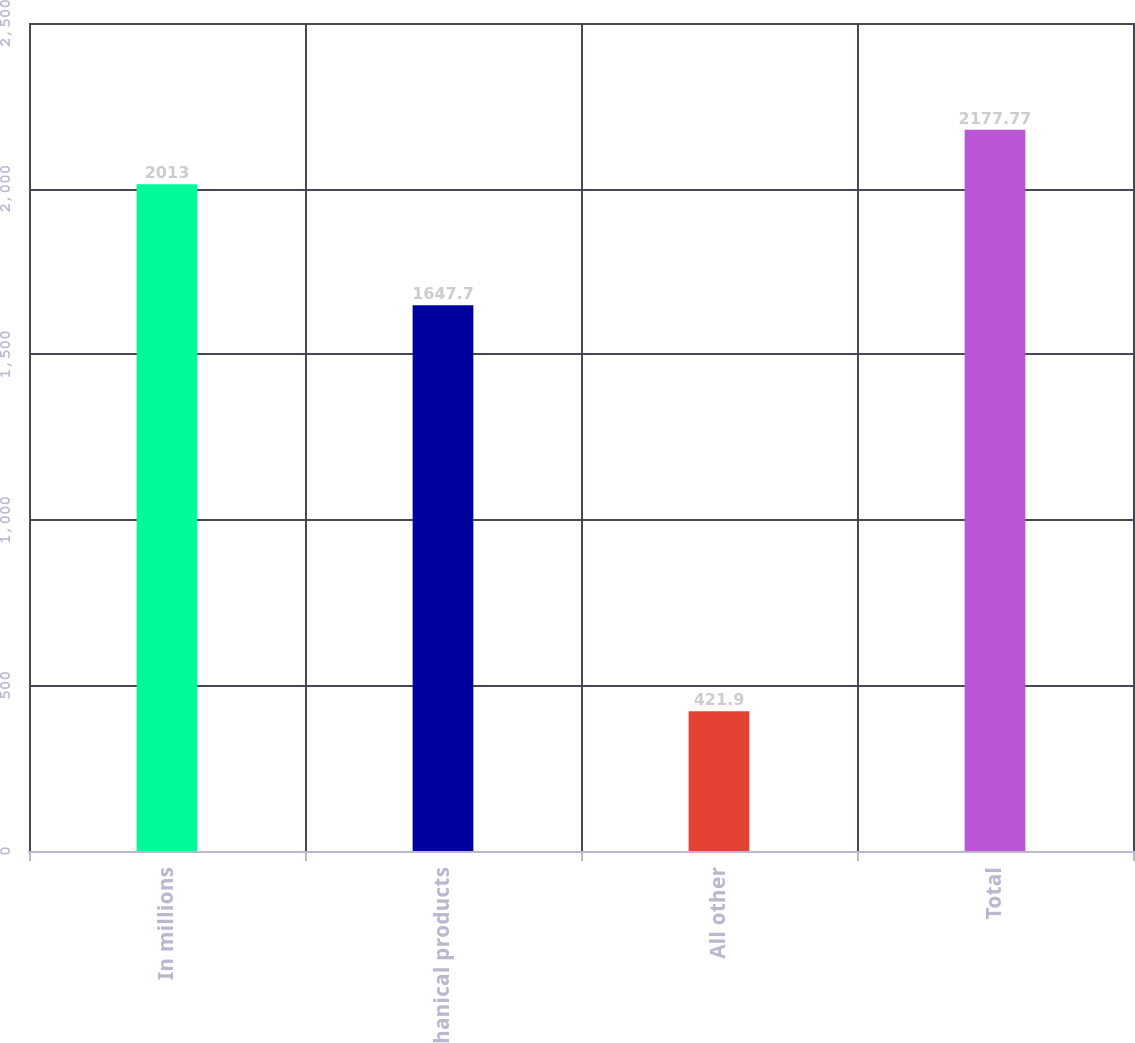<chart> <loc_0><loc_0><loc_500><loc_500><bar_chart><fcel>In millions<fcel>Mechanical products<fcel>All other<fcel>Total<nl><fcel>2013<fcel>1647.7<fcel>421.9<fcel>2177.77<nl></chart> 